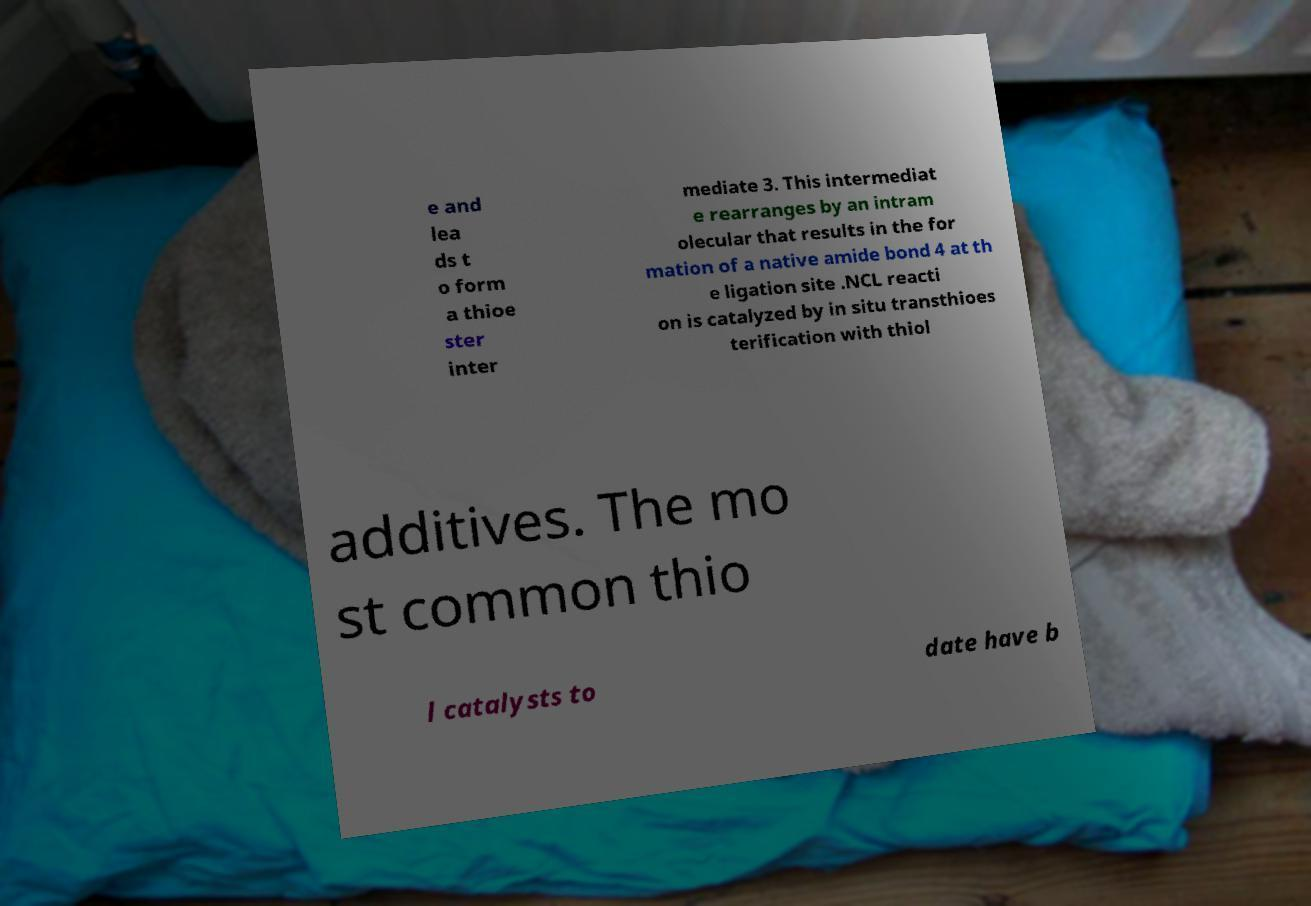There's text embedded in this image that I need extracted. Can you transcribe it verbatim? e and lea ds t o form a thioe ster inter mediate 3. This intermediat e rearranges by an intram olecular that results in the for mation of a native amide bond 4 at th e ligation site .NCL reacti on is catalyzed by in situ transthioes terification with thiol additives. The mo st common thio l catalysts to date have b 